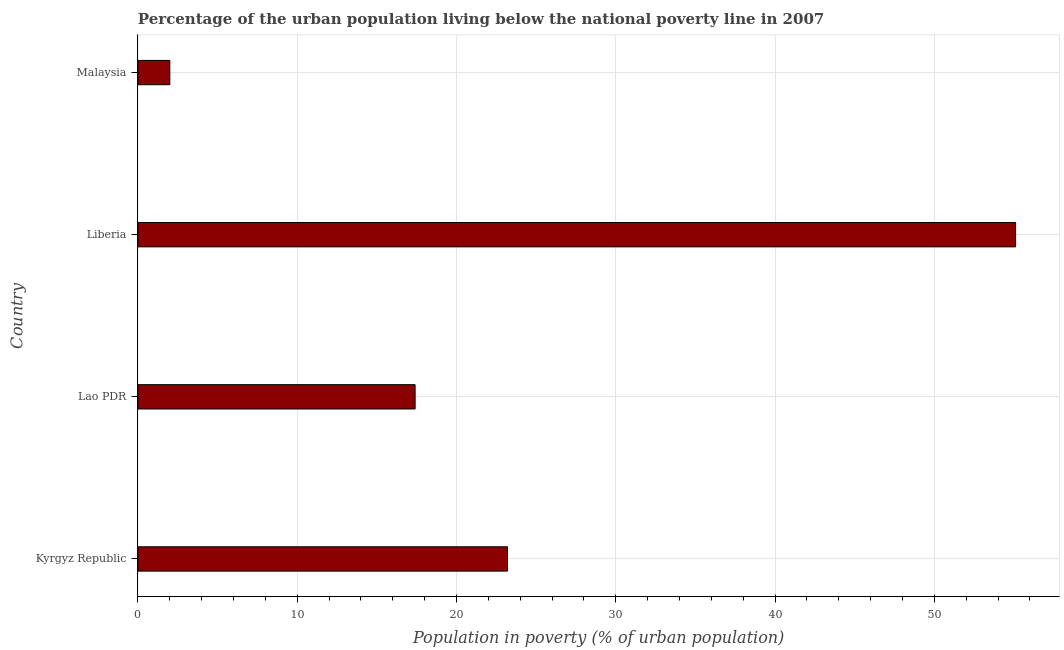Does the graph contain grids?
Your response must be concise. Yes. What is the title of the graph?
Provide a succinct answer. Percentage of the urban population living below the national poverty line in 2007. What is the label or title of the X-axis?
Offer a very short reply. Population in poverty (% of urban population). What is the percentage of urban population living below poverty line in Lao PDR?
Provide a succinct answer. 17.4. Across all countries, what is the maximum percentage of urban population living below poverty line?
Keep it short and to the point. 55.1. In which country was the percentage of urban population living below poverty line maximum?
Your answer should be compact. Liberia. In which country was the percentage of urban population living below poverty line minimum?
Provide a succinct answer. Malaysia. What is the sum of the percentage of urban population living below poverty line?
Offer a very short reply. 97.7. What is the difference between the percentage of urban population living below poverty line in Lao PDR and Malaysia?
Give a very brief answer. 15.4. What is the average percentage of urban population living below poverty line per country?
Ensure brevity in your answer.  24.43. What is the median percentage of urban population living below poverty line?
Give a very brief answer. 20.3. In how many countries, is the percentage of urban population living below poverty line greater than 10 %?
Offer a very short reply. 3. What is the ratio of the percentage of urban population living below poverty line in Kyrgyz Republic to that in Lao PDR?
Make the answer very short. 1.33. Is the difference between the percentage of urban population living below poverty line in Lao PDR and Liberia greater than the difference between any two countries?
Your answer should be compact. No. What is the difference between the highest and the second highest percentage of urban population living below poverty line?
Make the answer very short. 31.9. Is the sum of the percentage of urban population living below poverty line in Kyrgyz Republic and Liberia greater than the maximum percentage of urban population living below poverty line across all countries?
Give a very brief answer. Yes. What is the difference between the highest and the lowest percentage of urban population living below poverty line?
Offer a terse response. 53.1. In how many countries, is the percentage of urban population living below poverty line greater than the average percentage of urban population living below poverty line taken over all countries?
Keep it short and to the point. 1. How many bars are there?
Provide a succinct answer. 4. What is the Population in poverty (% of urban population) of Kyrgyz Republic?
Keep it short and to the point. 23.2. What is the Population in poverty (% of urban population) of Lao PDR?
Keep it short and to the point. 17.4. What is the Population in poverty (% of urban population) in Liberia?
Provide a short and direct response. 55.1. What is the Population in poverty (% of urban population) of Malaysia?
Keep it short and to the point. 2. What is the difference between the Population in poverty (% of urban population) in Kyrgyz Republic and Lao PDR?
Provide a short and direct response. 5.8. What is the difference between the Population in poverty (% of urban population) in Kyrgyz Republic and Liberia?
Give a very brief answer. -31.9. What is the difference between the Population in poverty (% of urban population) in Kyrgyz Republic and Malaysia?
Make the answer very short. 21.2. What is the difference between the Population in poverty (% of urban population) in Lao PDR and Liberia?
Your answer should be very brief. -37.7. What is the difference between the Population in poverty (% of urban population) in Lao PDR and Malaysia?
Your response must be concise. 15.4. What is the difference between the Population in poverty (% of urban population) in Liberia and Malaysia?
Provide a succinct answer. 53.1. What is the ratio of the Population in poverty (% of urban population) in Kyrgyz Republic to that in Lao PDR?
Your answer should be compact. 1.33. What is the ratio of the Population in poverty (% of urban population) in Kyrgyz Republic to that in Liberia?
Ensure brevity in your answer.  0.42. What is the ratio of the Population in poverty (% of urban population) in Lao PDR to that in Liberia?
Keep it short and to the point. 0.32. What is the ratio of the Population in poverty (% of urban population) in Liberia to that in Malaysia?
Make the answer very short. 27.55. 